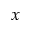<formula> <loc_0><loc_0><loc_500><loc_500>x</formula> 